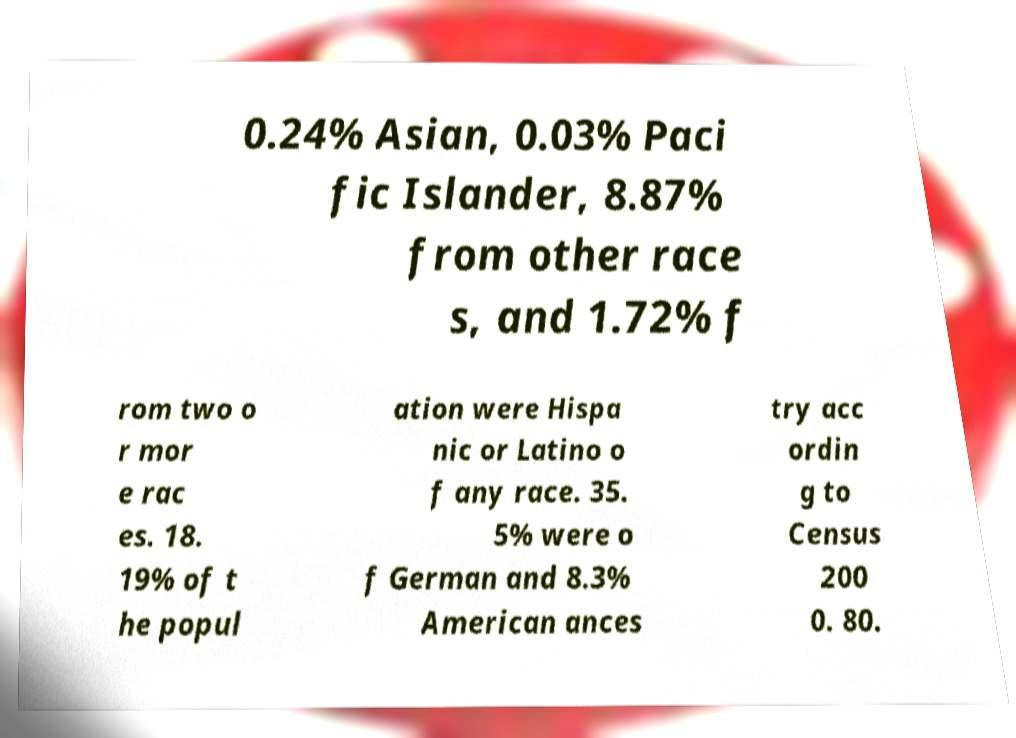What messages or text are displayed in this image? I need them in a readable, typed format. 0.24% Asian, 0.03% Paci fic Islander, 8.87% from other race s, and 1.72% f rom two o r mor e rac es. 18. 19% of t he popul ation were Hispa nic or Latino o f any race. 35. 5% were o f German and 8.3% American ances try acc ordin g to Census 200 0. 80. 